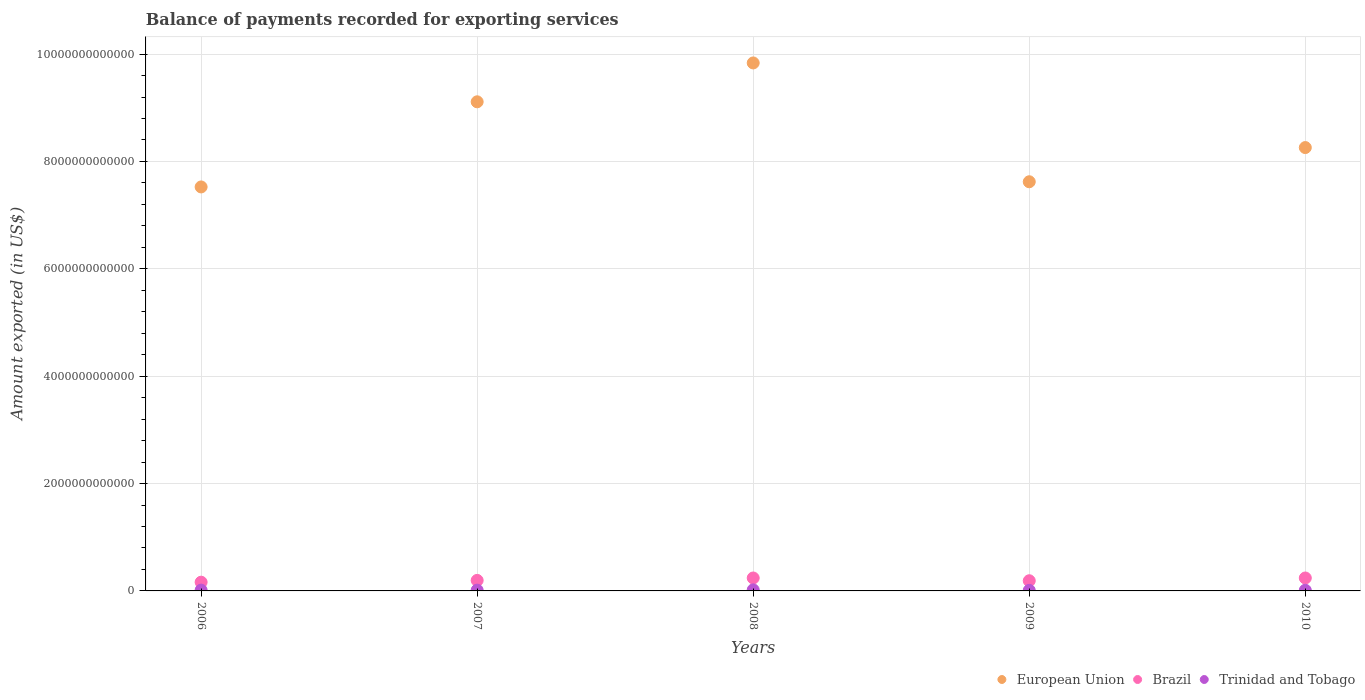Is the number of dotlines equal to the number of legend labels?
Your response must be concise. Yes. What is the amount exported in Trinidad and Tobago in 2009?
Your answer should be very brief. 1.03e+1. Across all years, what is the maximum amount exported in Trinidad and Tobago?
Provide a short and direct response. 1.99e+1. Across all years, what is the minimum amount exported in Trinidad and Tobago?
Ensure brevity in your answer.  1.03e+1. In which year was the amount exported in Trinidad and Tobago maximum?
Ensure brevity in your answer.  2008. In which year was the amount exported in European Union minimum?
Make the answer very short. 2006. What is the total amount exported in Trinidad and Tobago in the graph?
Your answer should be very brief. 7.21e+1. What is the difference between the amount exported in European Union in 2009 and that in 2010?
Your answer should be compact. -6.37e+11. What is the difference between the amount exported in European Union in 2009 and the amount exported in Trinidad and Tobago in 2007?
Offer a very short reply. 7.61e+12. What is the average amount exported in Brazil per year?
Give a very brief answer. 2.06e+11. In the year 2006, what is the difference between the amount exported in Brazil and amount exported in Trinidad and Tobago?
Offer a very short reply. 1.48e+11. In how many years, is the amount exported in European Union greater than 2000000000000 US$?
Provide a succinct answer. 5. What is the ratio of the amount exported in Trinidad and Tobago in 2007 to that in 2008?
Offer a terse response. 0.72. Is the amount exported in European Union in 2009 less than that in 2010?
Give a very brief answer. Yes. Is the difference between the amount exported in Brazil in 2008 and 2010 greater than the difference between the amount exported in Trinidad and Tobago in 2008 and 2010?
Keep it short and to the point. No. What is the difference between the highest and the second highest amount exported in Trinidad and Tobago?
Your response must be concise. 4.73e+09. What is the difference between the highest and the lowest amount exported in European Union?
Ensure brevity in your answer.  2.31e+12. In how many years, is the amount exported in Trinidad and Tobago greater than the average amount exported in Trinidad and Tobago taken over all years?
Keep it short and to the point. 2. Is the sum of the amount exported in European Union in 2007 and 2009 greater than the maximum amount exported in Brazil across all years?
Offer a terse response. Yes. Does the amount exported in Trinidad and Tobago monotonically increase over the years?
Your response must be concise. No. Is the amount exported in Trinidad and Tobago strictly greater than the amount exported in European Union over the years?
Your response must be concise. No. What is the difference between two consecutive major ticks on the Y-axis?
Offer a terse response. 2.00e+12. Does the graph contain any zero values?
Give a very brief answer. No. How are the legend labels stacked?
Offer a very short reply. Horizontal. What is the title of the graph?
Offer a very short reply. Balance of payments recorded for exporting services. Does "Uzbekistan" appear as one of the legend labels in the graph?
Offer a terse response. No. What is the label or title of the Y-axis?
Your answer should be very brief. Amount exported (in US$). What is the Amount exported (in US$) in European Union in 2006?
Provide a short and direct response. 7.53e+12. What is the Amount exported (in US$) in Brazil in 2006?
Provide a succinct answer. 1.63e+11. What is the Amount exported (in US$) of Trinidad and Tobago in 2006?
Your response must be concise. 1.51e+1. What is the Amount exported (in US$) in European Union in 2007?
Your answer should be compact. 9.11e+12. What is the Amount exported (in US$) of Brazil in 2007?
Ensure brevity in your answer.  1.96e+11. What is the Amount exported (in US$) of Trinidad and Tobago in 2007?
Provide a succinct answer. 1.44e+1. What is the Amount exported (in US$) of European Union in 2008?
Your answer should be very brief. 9.84e+12. What is the Amount exported (in US$) in Brazil in 2008?
Provide a short and direct response. 2.41e+11. What is the Amount exported (in US$) in Trinidad and Tobago in 2008?
Your response must be concise. 1.99e+1. What is the Amount exported (in US$) of European Union in 2009?
Your answer should be very brief. 7.62e+12. What is the Amount exported (in US$) of Brazil in 2009?
Ensure brevity in your answer.  1.90e+11. What is the Amount exported (in US$) in Trinidad and Tobago in 2009?
Offer a terse response. 1.03e+1. What is the Amount exported (in US$) of European Union in 2010?
Offer a very short reply. 8.26e+12. What is the Amount exported (in US$) of Brazil in 2010?
Make the answer very short. 2.41e+11. What is the Amount exported (in US$) in Trinidad and Tobago in 2010?
Your answer should be compact. 1.24e+1. Across all years, what is the maximum Amount exported (in US$) in European Union?
Your answer should be compact. 9.84e+12. Across all years, what is the maximum Amount exported (in US$) of Brazil?
Offer a very short reply. 2.41e+11. Across all years, what is the maximum Amount exported (in US$) of Trinidad and Tobago?
Provide a succinct answer. 1.99e+1. Across all years, what is the minimum Amount exported (in US$) in European Union?
Provide a short and direct response. 7.53e+12. Across all years, what is the minimum Amount exported (in US$) of Brazil?
Make the answer very short. 1.63e+11. Across all years, what is the minimum Amount exported (in US$) in Trinidad and Tobago?
Give a very brief answer. 1.03e+1. What is the total Amount exported (in US$) in European Union in the graph?
Give a very brief answer. 4.24e+13. What is the total Amount exported (in US$) of Brazil in the graph?
Your response must be concise. 1.03e+12. What is the total Amount exported (in US$) of Trinidad and Tobago in the graph?
Your answer should be compact. 7.21e+1. What is the difference between the Amount exported (in US$) of European Union in 2006 and that in 2007?
Your answer should be compact. -1.59e+12. What is the difference between the Amount exported (in US$) of Brazil in 2006 and that in 2007?
Your answer should be very brief. -3.34e+1. What is the difference between the Amount exported (in US$) in Trinidad and Tobago in 2006 and that in 2007?
Provide a short and direct response. 7.53e+08. What is the difference between the Amount exported (in US$) in European Union in 2006 and that in 2008?
Provide a succinct answer. -2.31e+12. What is the difference between the Amount exported (in US$) in Brazil in 2006 and that in 2008?
Ensure brevity in your answer.  -7.82e+1. What is the difference between the Amount exported (in US$) of Trinidad and Tobago in 2006 and that in 2008?
Your answer should be very brief. -4.73e+09. What is the difference between the Amount exported (in US$) of European Union in 2006 and that in 2009?
Keep it short and to the point. -9.64e+1. What is the difference between the Amount exported (in US$) of Brazil in 2006 and that in 2009?
Offer a terse response. -2.68e+1. What is the difference between the Amount exported (in US$) of Trinidad and Tobago in 2006 and that in 2009?
Your answer should be very brief. 4.87e+09. What is the difference between the Amount exported (in US$) in European Union in 2006 and that in 2010?
Keep it short and to the point. -7.33e+11. What is the difference between the Amount exported (in US$) of Brazil in 2006 and that in 2010?
Ensure brevity in your answer.  -7.82e+1. What is the difference between the Amount exported (in US$) of Trinidad and Tobago in 2006 and that in 2010?
Your answer should be compact. 2.75e+09. What is the difference between the Amount exported (in US$) of European Union in 2007 and that in 2008?
Provide a short and direct response. -7.24e+11. What is the difference between the Amount exported (in US$) of Brazil in 2007 and that in 2008?
Your answer should be compact. -4.48e+1. What is the difference between the Amount exported (in US$) of Trinidad and Tobago in 2007 and that in 2008?
Make the answer very short. -5.48e+09. What is the difference between the Amount exported (in US$) of European Union in 2007 and that in 2009?
Give a very brief answer. 1.49e+12. What is the difference between the Amount exported (in US$) in Brazil in 2007 and that in 2009?
Provide a succinct answer. 6.53e+09. What is the difference between the Amount exported (in US$) in Trinidad and Tobago in 2007 and that in 2009?
Make the answer very short. 4.12e+09. What is the difference between the Amount exported (in US$) in European Union in 2007 and that in 2010?
Make the answer very short. 8.53e+11. What is the difference between the Amount exported (in US$) of Brazil in 2007 and that in 2010?
Offer a very short reply. -4.48e+1. What is the difference between the Amount exported (in US$) of Trinidad and Tobago in 2007 and that in 2010?
Your answer should be very brief. 2.00e+09. What is the difference between the Amount exported (in US$) of European Union in 2008 and that in 2009?
Ensure brevity in your answer.  2.21e+12. What is the difference between the Amount exported (in US$) in Brazil in 2008 and that in 2009?
Your answer should be compact. 5.13e+1. What is the difference between the Amount exported (in US$) of Trinidad and Tobago in 2008 and that in 2009?
Give a very brief answer. 9.60e+09. What is the difference between the Amount exported (in US$) in European Union in 2008 and that in 2010?
Offer a terse response. 1.58e+12. What is the difference between the Amount exported (in US$) in Brazil in 2008 and that in 2010?
Make the answer very short. -1.56e+07. What is the difference between the Amount exported (in US$) of Trinidad and Tobago in 2008 and that in 2010?
Your response must be concise. 7.47e+09. What is the difference between the Amount exported (in US$) in European Union in 2009 and that in 2010?
Keep it short and to the point. -6.37e+11. What is the difference between the Amount exported (in US$) in Brazil in 2009 and that in 2010?
Provide a succinct answer. -5.14e+1. What is the difference between the Amount exported (in US$) of Trinidad and Tobago in 2009 and that in 2010?
Your response must be concise. -2.13e+09. What is the difference between the Amount exported (in US$) of European Union in 2006 and the Amount exported (in US$) of Brazil in 2007?
Your response must be concise. 7.33e+12. What is the difference between the Amount exported (in US$) of European Union in 2006 and the Amount exported (in US$) of Trinidad and Tobago in 2007?
Offer a very short reply. 7.51e+12. What is the difference between the Amount exported (in US$) of Brazil in 2006 and the Amount exported (in US$) of Trinidad and Tobago in 2007?
Provide a succinct answer. 1.48e+11. What is the difference between the Amount exported (in US$) of European Union in 2006 and the Amount exported (in US$) of Brazil in 2008?
Offer a very short reply. 7.28e+12. What is the difference between the Amount exported (in US$) in European Union in 2006 and the Amount exported (in US$) in Trinidad and Tobago in 2008?
Offer a terse response. 7.51e+12. What is the difference between the Amount exported (in US$) of Brazil in 2006 and the Amount exported (in US$) of Trinidad and Tobago in 2008?
Give a very brief answer. 1.43e+11. What is the difference between the Amount exported (in US$) in European Union in 2006 and the Amount exported (in US$) in Brazil in 2009?
Your answer should be very brief. 7.34e+12. What is the difference between the Amount exported (in US$) in European Union in 2006 and the Amount exported (in US$) in Trinidad and Tobago in 2009?
Offer a terse response. 7.52e+12. What is the difference between the Amount exported (in US$) in Brazil in 2006 and the Amount exported (in US$) in Trinidad and Tobago in 2009?
Offer a very short reply. 1.52e+11. What is the difference between the Amount exported (in US$) in European Union in 2006 and the Amount exported (in US$) in Brazil in 2010?
Your answer should be very brief. 7.28e+12. What is the difference between the Amount exported (in US$) in European Union in 2006 and the Amount exported (in US$) in Trinidad and Tobago in 2010?
Your answer should be compact. 7.51e+12. What is the difference between the Amount exported (in US$) of Brazil in 2006 and the Amount exported (in US$) of Trinidad and Tobago in 2010?
Ensure brevity in your answer.  1.50e+11. What is the difference between the Amount exported (in US$) of European Union in 2007 and the Amount exported (in US$) of Brazil in 2008?
Provide a short and direct response. 8.87e+12. What is the difference between the Amount exported (in US$) in European Union in 2007 and the Amount exported (in US$) in Trinidad and Tobago in 2008?
Keep it short and to the point. 9.09e+12. What is the difference between the Amount exported (in US$) in Brazil in 2007 and the Amount exported (in US$) in Trinidad and Tobago in 2008?
Provide a short and direct response. 1.76e+11. What is the difference between the Amount exported (in US$) of European Union in 2007 and the Amount exported (in US$) of Brazil in 2009?
Your answer should be very brief. 8.92e+12. What is the difference between the Amount exported (in US$) in European Union in 2007 and the Amount exported (in US$) in Trinidad and Tobago in 2009?
Your answer should be very brief. 9.10e+12. What is the difference between the Amount exported (in US$) of Brazil in 2007 and the Amount exported (in US$) of Trinidad and Tobago in 2009?
Keep it short and to the point. 1.86e+11. What is the difference between the Amount exported (in US$) in European Union in 2007 and the Amount exported (in US$) in Brazil in 2010?
Your answer should be compact. 8.87e+12. What is the difference between the Amount exported (in US$) of European Union in 2007 and the Amount exported (in US$) of Trinidad and Tobago in 2010?
Make the answer very short. 9.10e+12. What is the difference between the Amount exported (in US$) of Brazil in 2007 and the Amount exported (in US$) of Trinidad and Tobago in 2010?
Your response must be concise. 1.84e+11. What is the difference between the Amount exported (in US$) in European Union in 2008 and the Amount exported (in US$) in Brazil in 2009?
Keep it short and to the point. 9.65e+12. What is the difference between the Amount exported (in US$) in European Union in 2008 and the Amount exported (in US$) in Trinidad and Tobago in 2009?
Provide a succinct answer. 9.82e+12. What is the difference between the Amount exported (in US$) in Brazil in 2008 and the Amount exported (in US$) in Trinidad and Tobago in 2009?
Provide a succinct answer. 2.31e+11. What is the difference between the Amount exported (in US$) in European Union in 2008 and the Amount exported (in US$) in Brazil in 2010?
Keep it short and to the point. 9.59e+12. What is the difference between the Amount exported (in US$) of European Union in 2008 and the Amount exported (in US$) of Trinidad and Tobago in 2010?
Provide a succinct answer. 9.82e+12. What is the difference between the Amount exported (in US$) of Brazil in 2008 and the Amount exported (in US$) of Trinidad and Tobago in 2010?
Provide a succinct answer. 2.29e+11. What is the difference between the Amount exported (in US$) in European Union in 2009 and the Amount exported (in US$) in Brazil in 2010?
Offer a terse response. 7.38e+12. What is the difference between the Amount exported (in US$) in European Union in 2009 and the Amount exported (in US$) in Trinidad and Tobago in 2010?
Offer a very short reply. 7.61e+12. What is the difference between the Amount exported (in US$) in Brazil in 2009 and the Amount exported (in US$) in Trinidad and Tobago in 2010?
Offer a very short reply. 1.77e+11. What is the average Amount exported (in US$) of European Union per year?
Provide a succinct answer. 8.47e+12. What is the average Amount exported (in US$) of Brazil per year?
Offer a very short reply. 2.06e+11. What is the average Amount exported (in US$) of Trinidad and Tobago per year?
Provide a short and direct response. 1.44e+1. In the year 2006, what is the difference between the Amount exported (in US$) in European Union and Amount exported (in US$) in Brazil?
Give a very brief answer. 7.36e+12. In the year 2006, what is the difference between the Amount exported (in US$) of European Union and Amount exported (in US$) of Trinidad and Tobago?
Ensure brevity in your answer.  7.51e+12. In the year 2006, what is the difference between the Amount exported (in US$) of Brazil and Amount exported (in US$) of Trinidad and Tobago?
Offer a very short reply. 1.48e+11. In the year 2007, what is the difference between the Amount exported (in US$) of European Union and Amount exported (in US$) of Brazil?
Keep it short and to the point. 8.92e+12. In the year 2007, what is the difference between the Amount exported (in US$) in European Union and Amount exported (in US$) in Trinidad and Tobago?
Provide a succinct answer. 9.10e+12. In the year 2007, what is the difference between the Amount exported (in US$) of Brazil and Amount exported (in US$) of Trinidad and Tobago?
Offer a terse response. 1.82e+11. In the year 2008, what is the difference between the Amount exported (in US$) in European Union and Amount exported (in US$) in Brazil?
Offer a very short reply. 9.59e+12. In the year 2008, what is the difference between the Amount exported (in US$) in European Union and Amount exported (in US$) in Trinidad and Tobago?
Your answer should be compact. 9.82e+12. In the year 2008, what is the difference between the Amount exported (in US$) in Brazil and Amount exported (in US$) in Trinidad and Tobago?
Your answer should be compact. 2.21e+11. In the year 2009, what is the difference between the Amount exported (in US$) in European Union and Amount exported (in US$) in Brazil?
Offer a very short reply. 7.43e+12. In the year 2009, what is the difference between the Amount exported (in US$) in European Union and Amount exported (in US$) in Trinidad and Tobago?
Ensure brevity in your answer.  7.61e+12. In the year 2009, what is the difference between the Amount exported (in US$) in Brazil and Amount exported (in US$) in Trinidad and Tobago?
Ensure brevity in your answer.  1.79e+11. In the year 2010, what is the difference between the Amount exported (in US$) in European Union and Amount exported (in US$) in Brazil?
Ensure brevity in your answer.  8.02e+12. In the year 2010, what is the difference between the Amount exported (in US$) in European Union and Amount exported (in US$) in Trinidad and Tobago?
Keep it short and to the point. 8.25e+12. In the year 2010, what is the difference between the Amount exported (in US$) of Brazil and Amount exported (in US$) of Trinidad and Tobago?
Ensure brevity in your answer.  2.29e+11. What is the ratio of the Amount exported (in US$) of European Union in 2006 to that in 2007?
Your answer should be very brief. 0.83. What is the ratio of the Amount exported (in US$) of Brazil in 2006 to that in 2007?
Provide a short and direct response. 0.83. What is the ratio of the Amount exported (in US$) in Trinidad and Tobago in 2006 to that in 2007?
Provide a short and direct response. 1.05. What is the ratio of the Amount exported (in US$) in European Union in 2006 to that in 2008?
Your response must be concise. 0.77. What is the ratio of the Amount exported (in US$) in Brazil in 2006 to that in 2008?
Keep it short and to the point. 0.68. What is the ratio of the Amount exported (in US$) of Trinidad and Tobago in 2006 to that in 2008?
Provide a succinct answer. 0.76. What is the ratio of the Amount exported (in US$) of European Union in 2006 to that in 2009?
Your response must be concise. 0.99. What is the ratio of the Amount exported (in US$) in Brazil in 2006 to that in 2009?
Your response must be concise. 0.86. What is the ratio of the Amount exported (in US$) in Trinidad and Tobago in 2006 to that in 2009?
Provide a succinct answer. 1.47. What is the ratio of the Amount exported (in US$) in European Union in 2006 to that in 2010?
Offer a terse response. 0.91. What is the ratio of the Amount exported (in US$) of Brazil in 2006 to that in 2010?
Ensure brevity in your answer.  0.68. What is the ratio of the Amount exported (in US$) in Trinidad and Tobago in 2006 to that in 2010?
Offer a terse response. 1.22. What is the ratio of the Amount exported (in US$) of European Union in 2007 to that in 2008?
Make the answer very short. 0.93. What is the ratio of the Amount exported (in US$) in Brazil in 2007 to that in 2008?
Offer a terse response. 0.81. What is the ratio of the Amount exported (in US$) in Trinidad and Tobago in 2007 to that in 2008?
Your response must be concise. 0.72. What is the ratio of the Amount exported (in US$) of European Union in 2007 to that in 2009?
Offer a very short reply. 1.2. What is the ratio of the Amount exported (in US$) of Brazil in 2007 to that in 2009?
Keep it short and to the point. 1.03. What is the ratio of the Amount exported (in US$) in Trinidad and Tobago in 2007 to that in 2009?
Provide a short and direct response. 1.4. What is the ratio of the Amount exported (in US$) of European Union in 2007 to that in 2010?
Keep it short and to the point. 1.1. What is the ratio of the Amount exported (in US$) of Brazil in 2007 to that in 2010?
Offer a very short reply. 0.81. What is the ratio of the Amount exported (in US$) of Trinidad and Tobago in 2007 to that in 2010?
Your answer should be very brief. 1.16. What is the ratio of the Amount exported (in US$) of European Union in 2008 to that in 2009?
Your answer should be compact. 1.29. What is the ratio of the Amount exported (in US$) in Brazil in 2008 to that in 2009?
Your response must be concise. 1.27. What is the ratio of the Amount exported (in US$) of Trinidad and Tobago in 2008 to that in 2009?
Make the answer very short. 1.94. What is the ratio of the Amount exported (in US$) of European Union in 2008 to that in 2010?
Offer a very short reply. 1.19. What is the ratio of the Amount exported (in US$) of Brazil in 2008 to that in 2010?
Make the answer very short. 1. What is the ratio of the Amount exported (in US$) in Trinidad and Tobago in 2008 to that in 2010?
Offer a very short reply. 1.6. What is the ratio of the Amount exported (in US$) in European Union in 2009 to that in 2010?
Give a very brief answer. 0.92. What is the ratio of the Amount exported (in US$) in Brazil in 2009 to that in 2010?
Your answer should be compact. 0.79. What is the ratio of the Amount exported (in US$) in Trinidad and Tobago in 2009 to that in 2010?
Offer a terse response. 0.83. What is the difference between the highest and the second highest Amount exported (in US$) in European Union?
Give a very brief answer. 7.24e+11. What is the difference between the highest and the second highest Amount exported (in US$) in Brazil?
Give a very brief answer. 1.56e+07. What is the difference between the highest and the second highest Amount exported (in US$) in Trinidad and Tobago?
Ensure brevity in your answer.  4.73e+09. What is the difference between the highest and the lowest Amount exported (in US$) in European Union?
Your answer should be compact. 2.31e+12. What is the difference between the highest and the lowest Amount exported (in US$) of Brazil?
Offer a terse response. 7.82e+1. What is the difference between the highest and the lowest Amount exported (in US$) of Trinidad and Tobago?
Provide a short and direct response. 9.60e+09. 